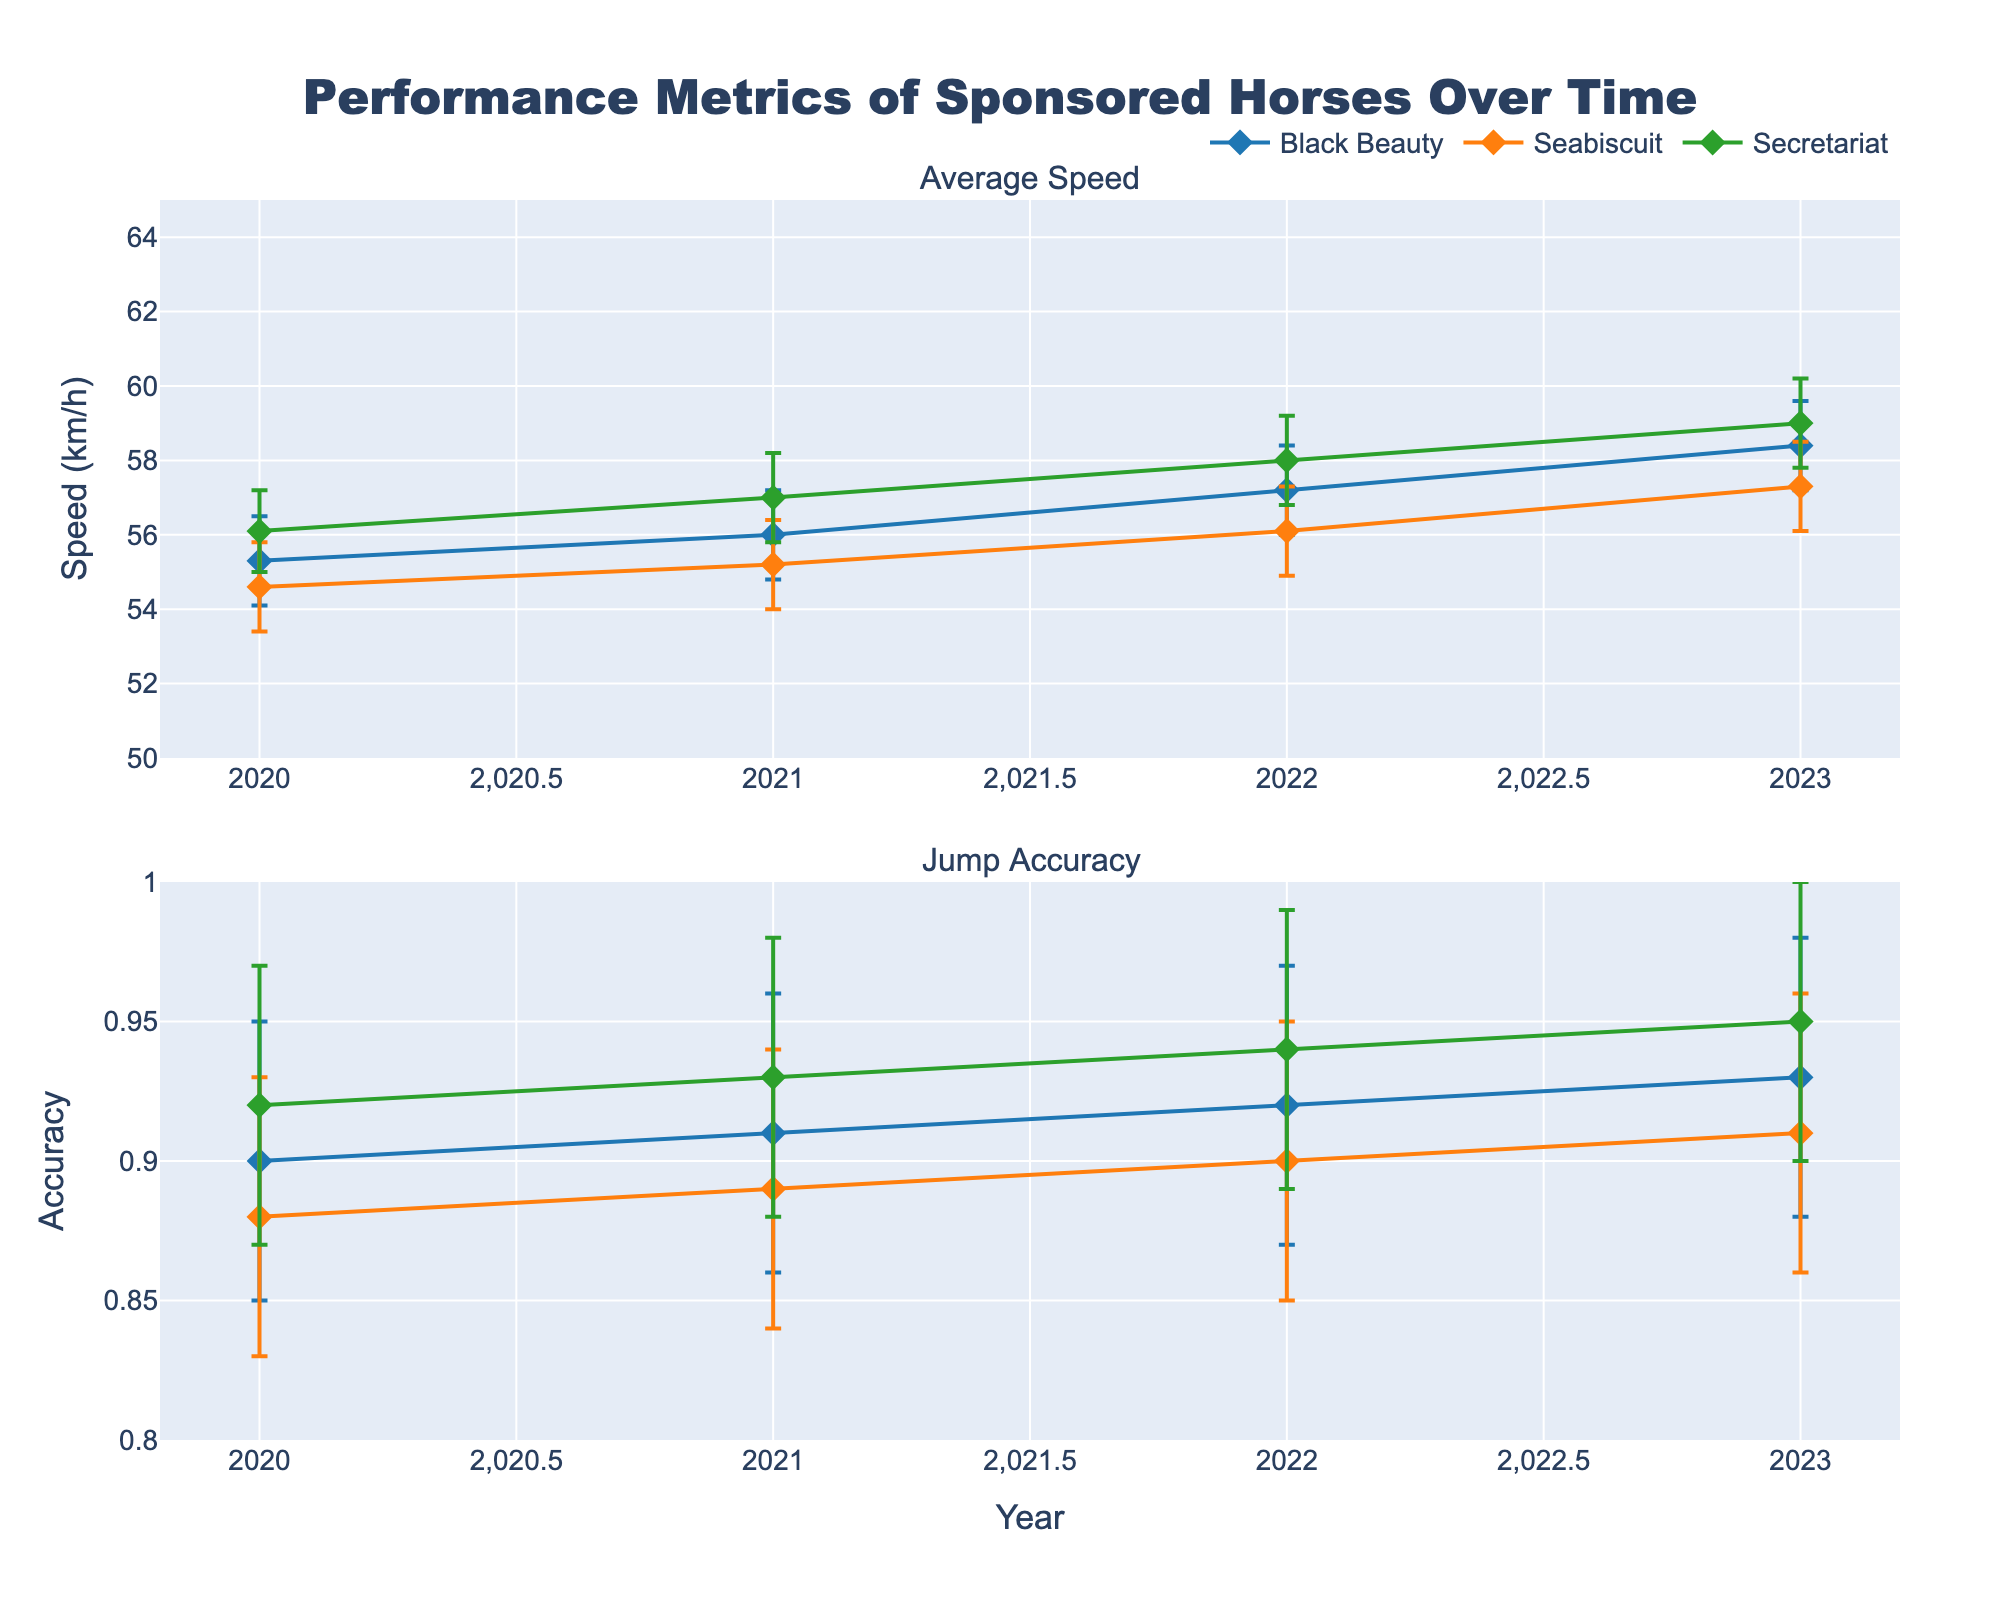What is the title of the figure? The title of the figure is displayed at the top and reads "Performance Metrics of Sponsored Horses Over Time".
Answer: Performance Metrics of Sponsored Horses Over Time What are the two metrics shown in the figure? The two subplots have their titles and y-axis labels indicating the metrics. They are "Average Speed" and "Jump Accuracy".
Answer: Average Speed and Jump Accuracy Which horse had the highest average speed in 2023? By looking at the data points on the "Average Speed" subplot for 2023, Secretariat has the highest average speed.
Answer: Secretariat What is the highest jump accuracy achieved by any horse in 2021? The "Jump Accuracy" subplot shows the data points for each year. In 2021, Secretariat achieved the highest accuracy of 0.93.
Answer: 0.93 Which horse shows the most improvement in average speed from 2020 to 2023? To find the most improvement, calculate the difference in average speed for each horse between 2020 and 2023 and compare. Secretariat's speed increased from 56.1 km/h in 2020 to 59.0 km/h in 2023, showing an increase of 2.9 km/h, which is the highest.
Answer: Secretariat Between Black Beauty and Seabiscuit, which horse had a smaller Interval Range for Average Speed in 2021? The Interval Range for Average Speed in 2021 can be calculated as the difference between the SpeedCI95_Upper and SpeedCI95_Lower for each horse. For Black Beauty, it is 57.2 - 54.8 = 2.4 km/h; for Seabiscuit, it is 56.4 - 54.0 = 2.4 km/h. Both horses have the same Interval Range in 2021.
Answer: Both have the same What is the trend in average speed for Black Beauty from 2020 to 2023? Looking at the "Average Speed" subplot for Black Beauty, the data points show a continuous increase from 2020 (55.3 km/h) to 2023 (58.4 km/h).
Answer: Increasing How do the confidence intervals for Jump Accuracy compare between Black Beauty and Secretariat in 2022? In 2022, for Jump Accuracy, Black Beauty has a confidence interval of 0.87 to 0.97, while Secretariat has a confidence interval of 0.89 to 0.99. Secretariat’s confidence interval is slightly higher in both lower and upper bounds.
Answer: Secretariat’s intervals are slightly higher Which year had the smallest error margin for Seabiscuit's Jump Accuracy? The error margin is the difference between AccuracyCI95_Upper and AccuracyCI95_Lower for each year. For Seabiscuit:
- 2020: 0.93 - 0.83 = 0.10
- 2021: 0.94 - 0.84 = 0.10
- 2022: 0.95 - 0.85 = 0.10
- 2023: 0.96 - 0.86 = 0.10
All years have an equal error margin of 0.10 for Seabiscuit's Jump Accuracy.
Answer: All years have the same error margin Rate of improvement in Secretariat's average speed per year between 2020 and 2023? Calculate the difference in average speed from 2020 to 2023, then divide by the number of years. Difference in average speed = 59.0 - 56.1 = 2.9 km/h; number of years = 3; rate of improvement = 2.9 km/h / 3 years = 0.967 km/h per year.
Answer: 0.967 km/h per year 